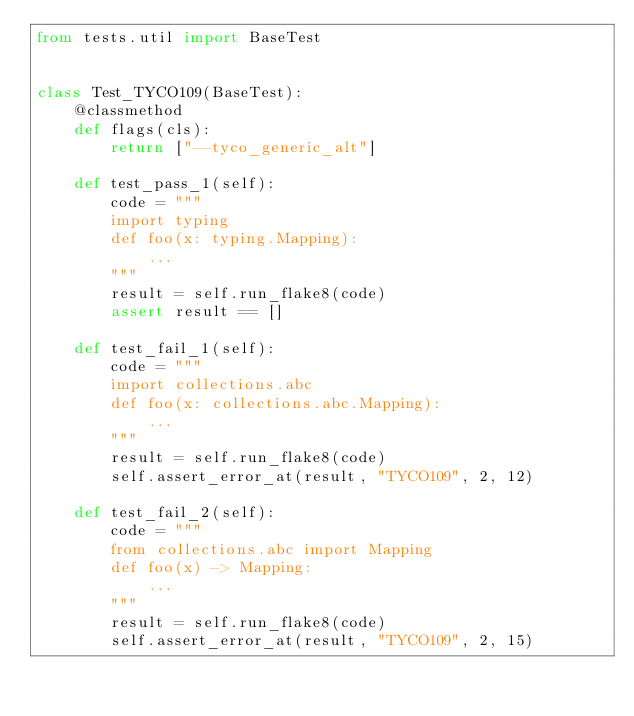<code> <loc_0><loc_0><loc_500><loc_500><_Python_>from tests.util import BaseTest


class Test_TYCO109(BaseTest):
    @classmethod
    def flags(cls):
        return ["--tyco_generic_alt"]

    def test_pass_1(self):
        code = """
        import typing
        def foo(x: typing.Mapping):
            ...
        """
        result = self.run_flake8(code)
        assert result == []

    def test_fail_1(self):
        code = """
        import collections.abc
        def foo(x: collections.abc.Mapping):
            ...
        """
        result = self.run_flake8(code)
        self.assert_error_at(result, "TYCO109", 2, 12)

    def test_fail_2(self):
        code = """
        from collections.abc import Mapping
        def foo(x) -> Mapping:
            ...
        """
        result = self.run_flake8(code)
        self.assert_error_at(result, "TYCO109", 2, 15)
</code> 